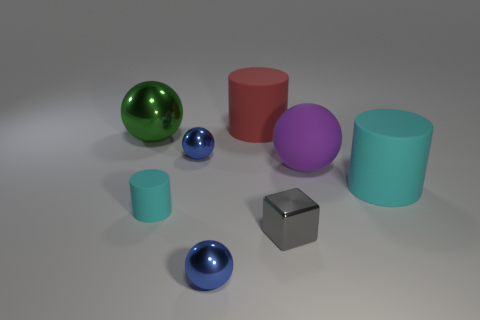Add 2 yellow rubber objects. How many objects exist? 10 Subtract all red rubber cylinders. How many cylinders are left? 2 Subtract all cylinders. How many objects are left? 5 Subtract all green balls. How many balls are left? 3 Subtract 3 cylinders. How many cylinders are left? 0 Subtract all brown cylinders. How many red blocks are left? 0 Subtract all red shiny cubes. Subtract all large red cylinders. How many objects are left? 7 Add 3 green spheres. How many green spheres are left? 4 Add 8 small purple shiny cylinders. How many small purple shiny cylinders exist? 8 Subtract 0 gray cylinders. How many objects are left? 8 